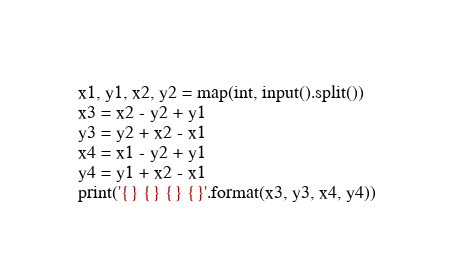Convert code to text. <code><loc_0><loc_0><loc_500><loc_500><_Python_>x1, y1, x2, y2 = map(int, input().split())
x3 = x2 - y2 + y1
y3 = y2 + x2 - x1
x4 = x1 - y2 + y1
y4 = y1 + x2 - x1
print('{} {} {} {}'.format(x3, y3, x4, y4))</code> 